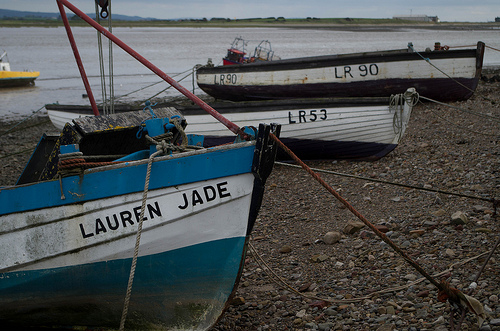What could 'LR' stand for in the context of these boats? 'LR' on these boats likely stands for a specific location's registration code, which helps in identifying the port or region the boat is registered with. It's a common practice for maritime vessels. 